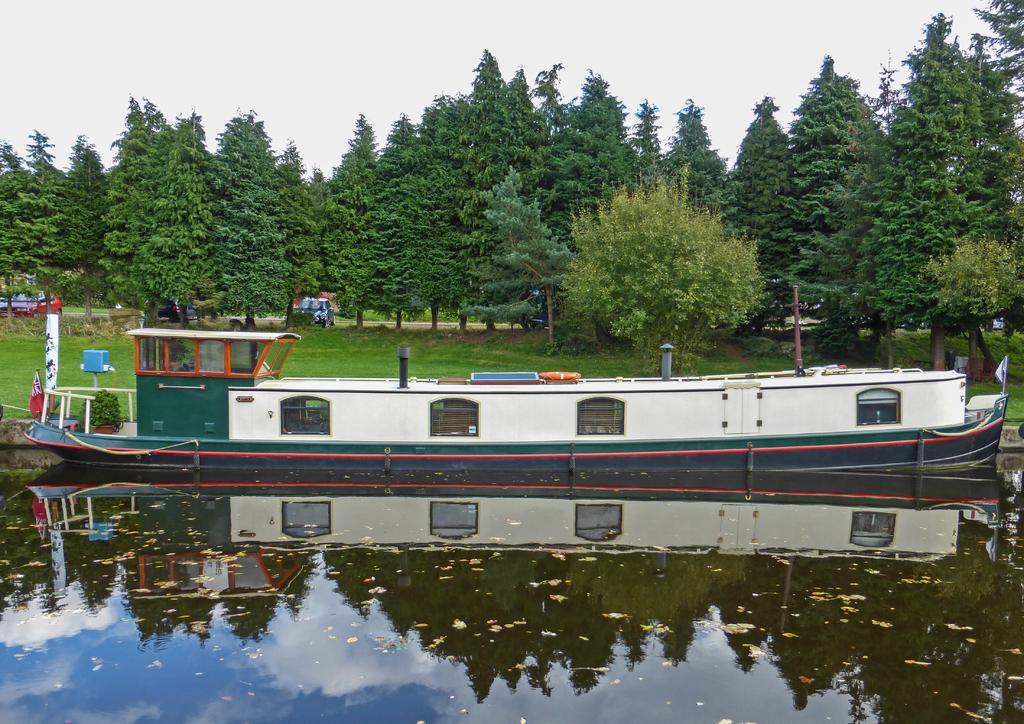Please provide a concise description of this image. In this picture we can see a boat on water, trees, vehicles on the road and in the background we can see the sky. 